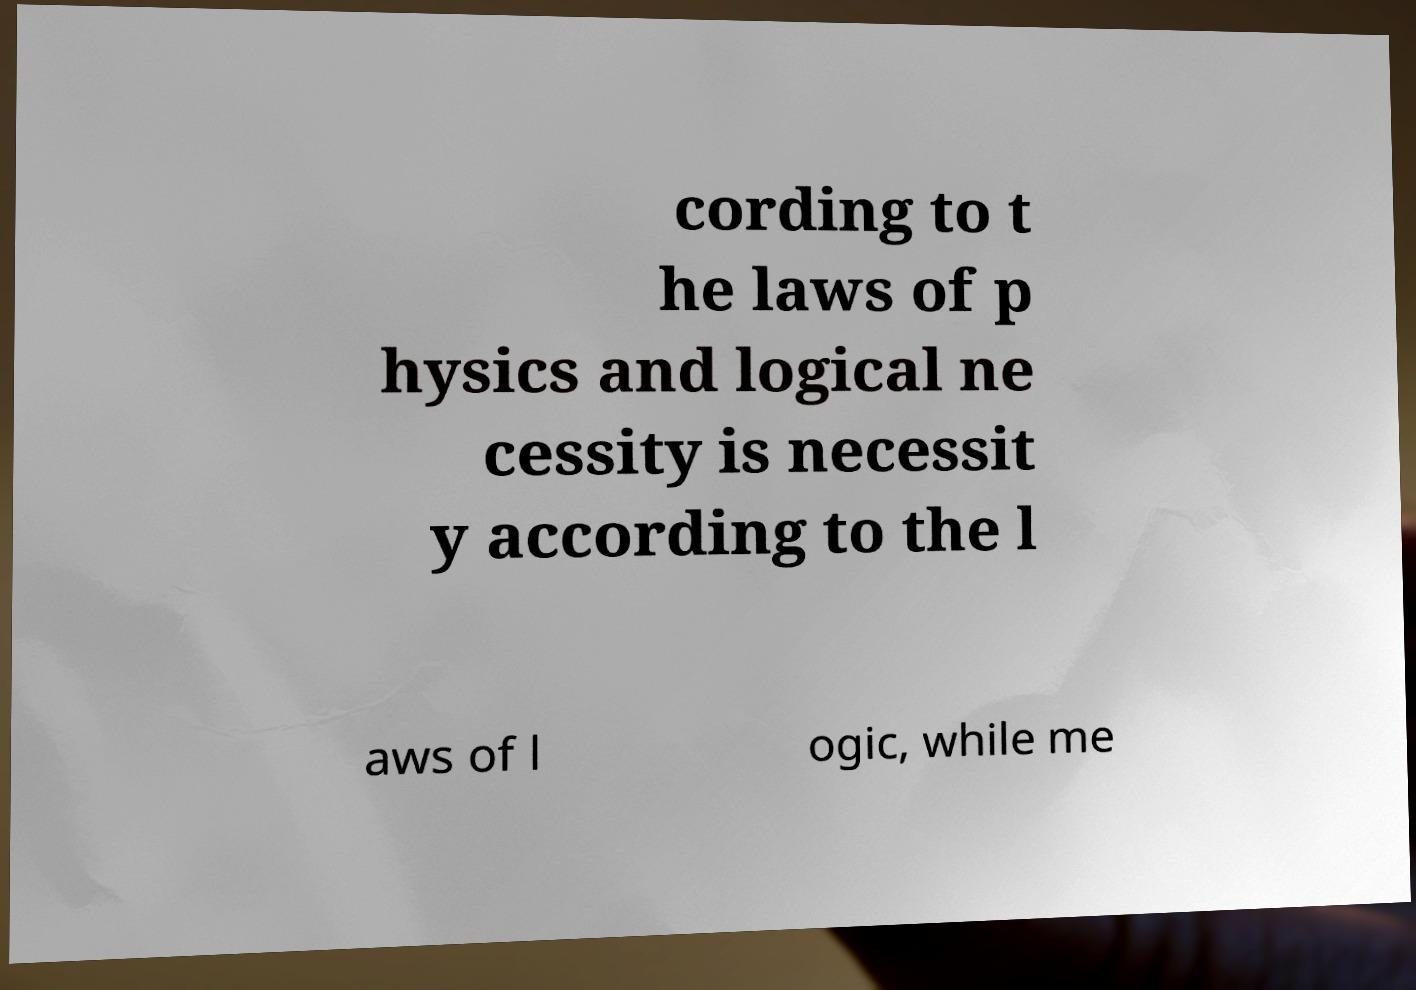I need the written content from this picture converted into text. Can you do that? cording to t he laws of p hysics and logical ne cessity is necessit y according to the l aws of l ogic, while me 